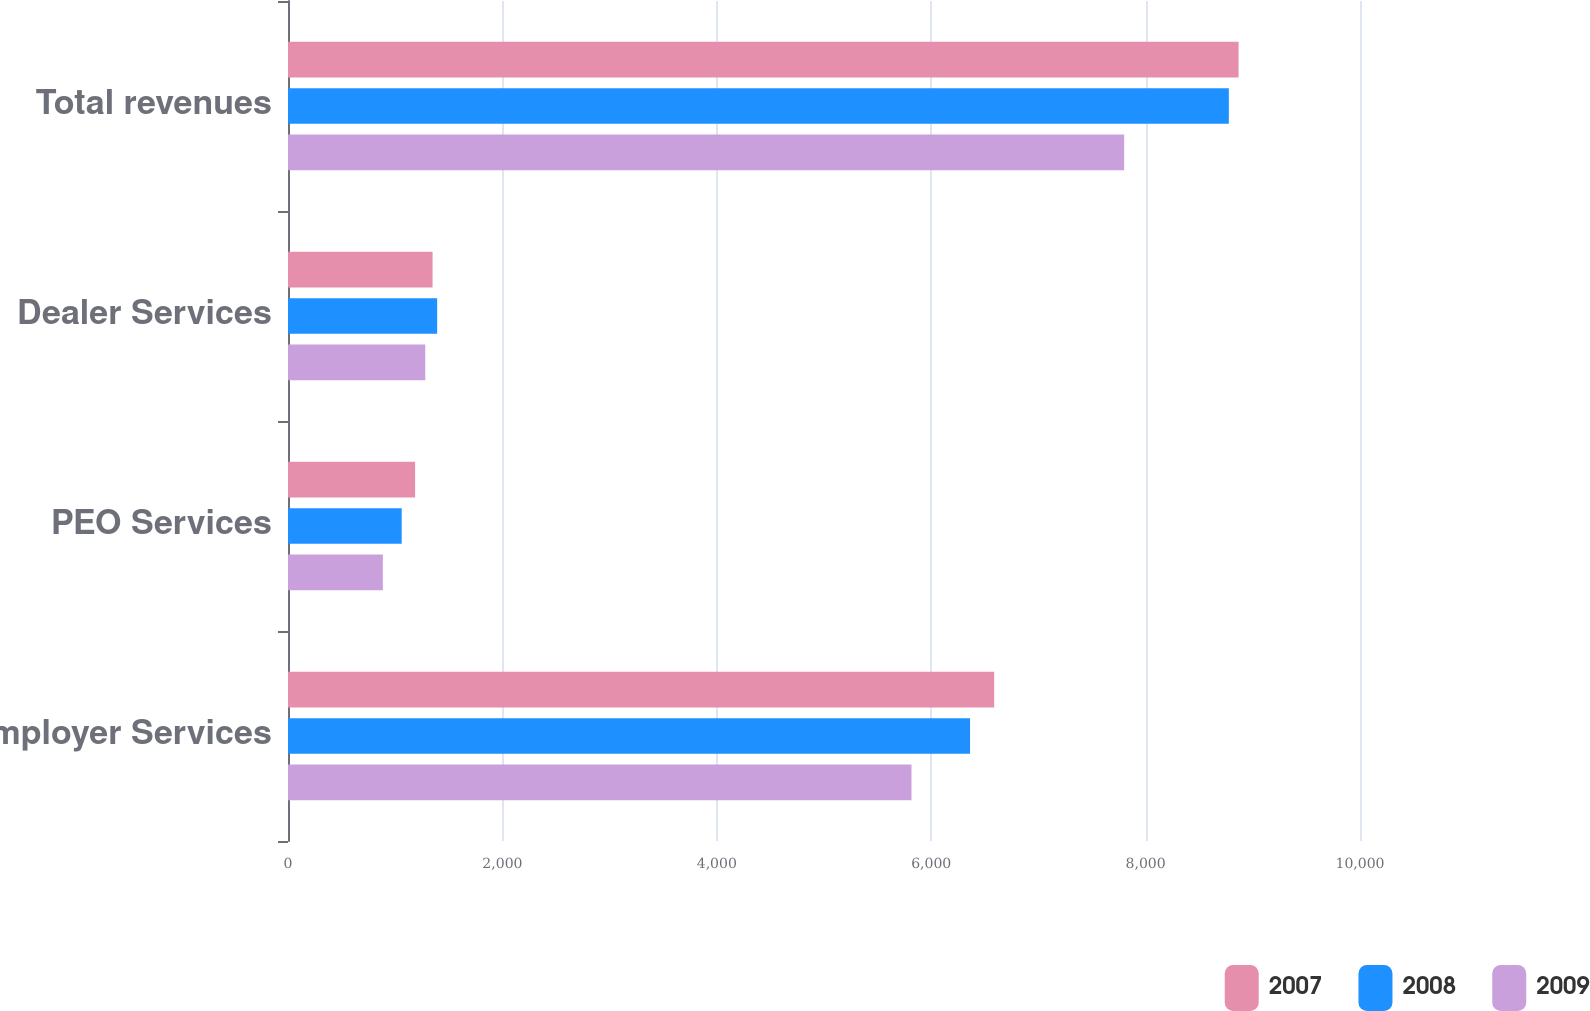<chart> <loc_0><loc_0><loc_500><loc_500><stacked_bar_chart><ecel><fcel>Employer Services<fcel>PEO Services<fcel>Dealer Services<fcel>Total revenues<nl><fcel>2007<fcel>6587.7<fcel>1185.8<fcel>1348.6<fcel>8867.1<nl><fcel>2008<fcel>6362.4<fcel>1060.5<fcel>1391.4<fcel>8776.5<nl><fcel>2009<fcel>5816.3<fcel>884.8<fcel>1280.6<fcel>7800<nl></chart> 